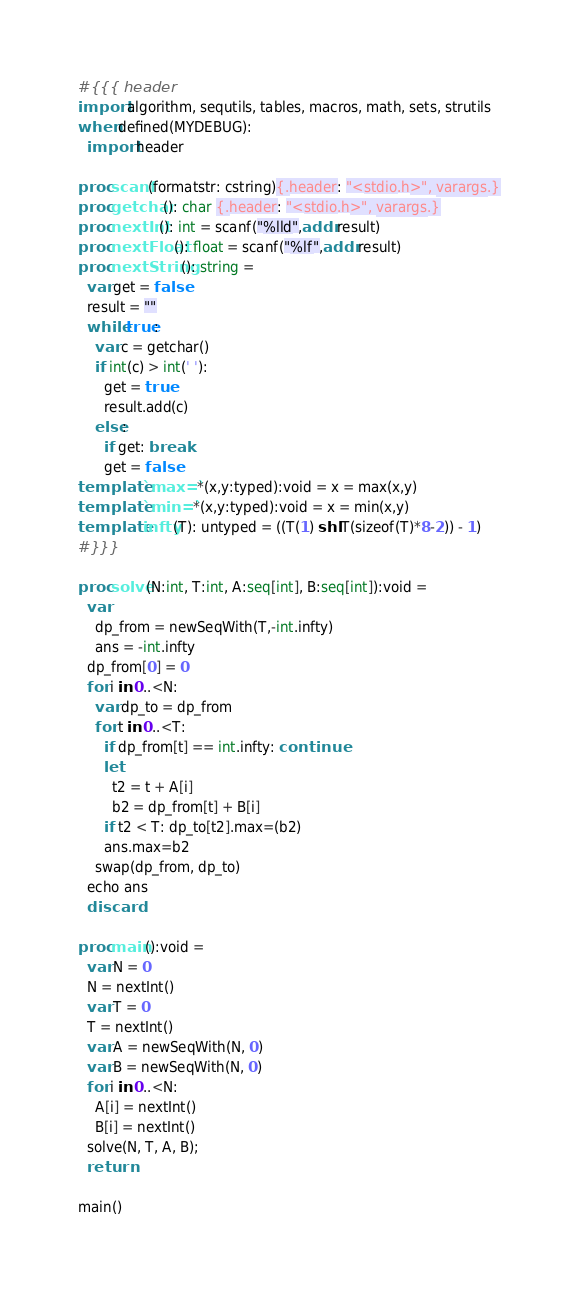<code> <loc_0><loc_0><loc_500><loc_500><_Nim_>#{{{ header
import algorithm, sequtils, tables, macros, math, sets, strutils
when defined(MYDEBUG):
  import header

proc scanf(formatstr: cstring){.header: "<stdio.h>", varargs.}
proc getchar(): char {.header: "<stdio.h>", varargs.}
proc nextInt(): int = scanf("%lld",addr result)
proc nextFloat(): float = scanf("%lf",addr result)
proc nextString(): string =
  var get = false
  result = ""
  while true:
    var c = getchar()
    if int(c) > int(' '):
      get = true
      result.add(c)
    else:
      if get: break
      get = false
template `max=`*(x,y:typed):void = x = max(x,y)
template `min=`*(x,y:typed):void = x = min(x,y)
template infty(T): untyped = ((T(1) shl T(sizeof(T)*8-2)) - 1)
#}}}

proc solve(N:int, T:int, A:seq[int], B:seq[int]):void =
  var 
    dp_from = newSeqWith(T,-int.infty)
    ans = -int.infty
  dp_from[0] = 0
  for i in 0..<N:
    var dp_to = dp_from
    for t in 0..<T:
      if dp_from[t] == int.infty: continue
      let
        t2 = t + A[i]
        b2 = dp_from[t] + B[i]
      if t2 < T: dp_to[t2].max=(b2)
      ans.max=b2
    swap(dp_from, dp_to)
  echo ans
  discard

proc main():void =
  var N = 0
  N = nextInt()
  var T = 0
  T = nextInt()
  var A = newSeqWith(N, 0)
  var B = newSeqWith(N, 0)
  for i in 0..<N:
    A[i] = nextInt()
    B[i] = nextInt()
  solve(N, T, A, B);
  return

main()
</code> 